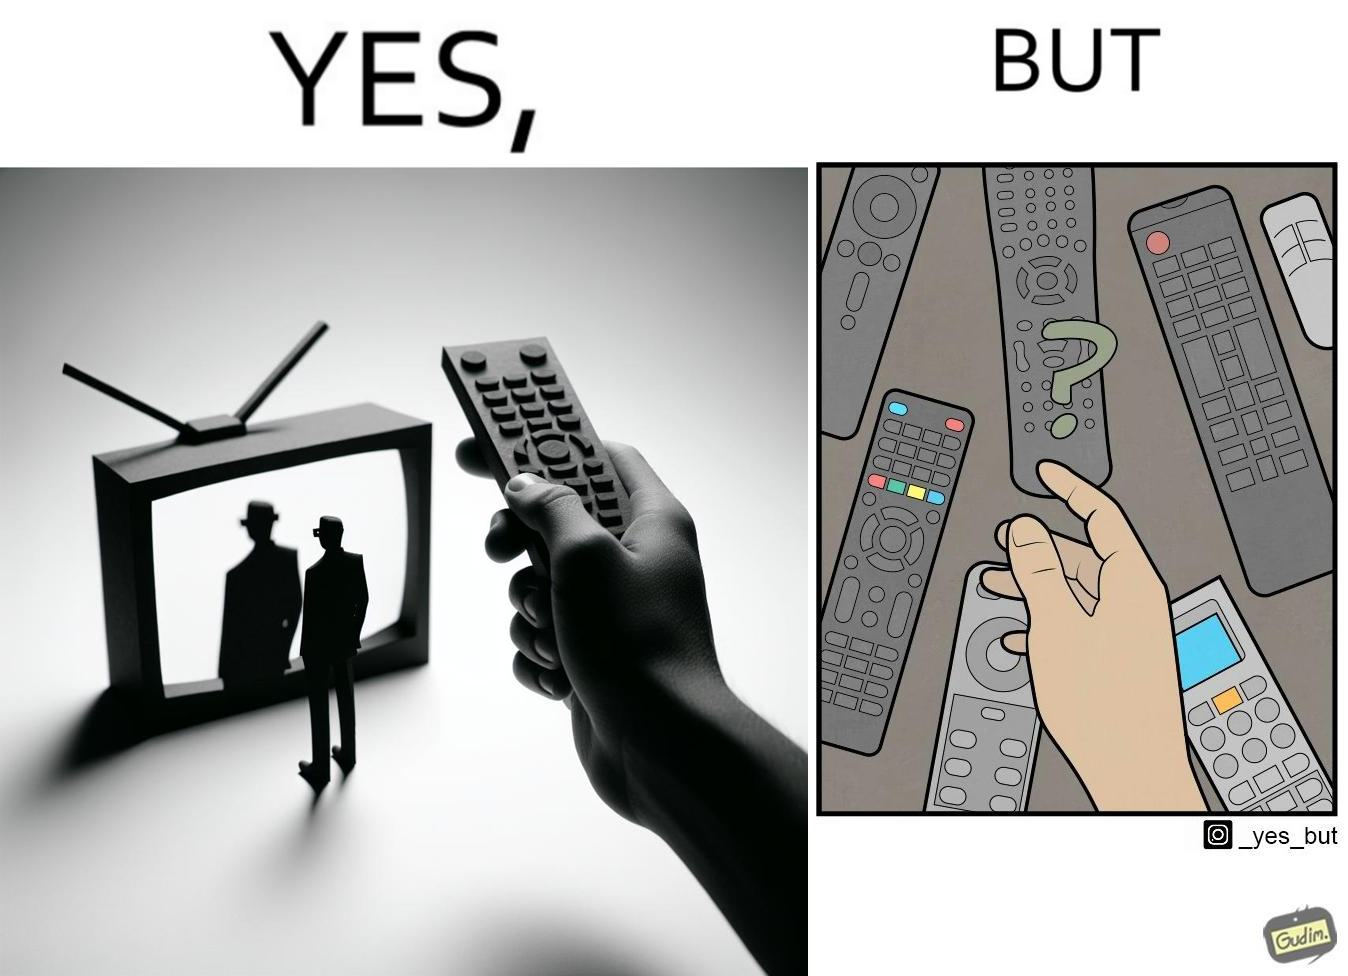Describe the contrast between the left and right parts of this image. In the left part of the image: It is a remote being used to operate a TV In the right part of the image: It is an user confused between multiple remotes 